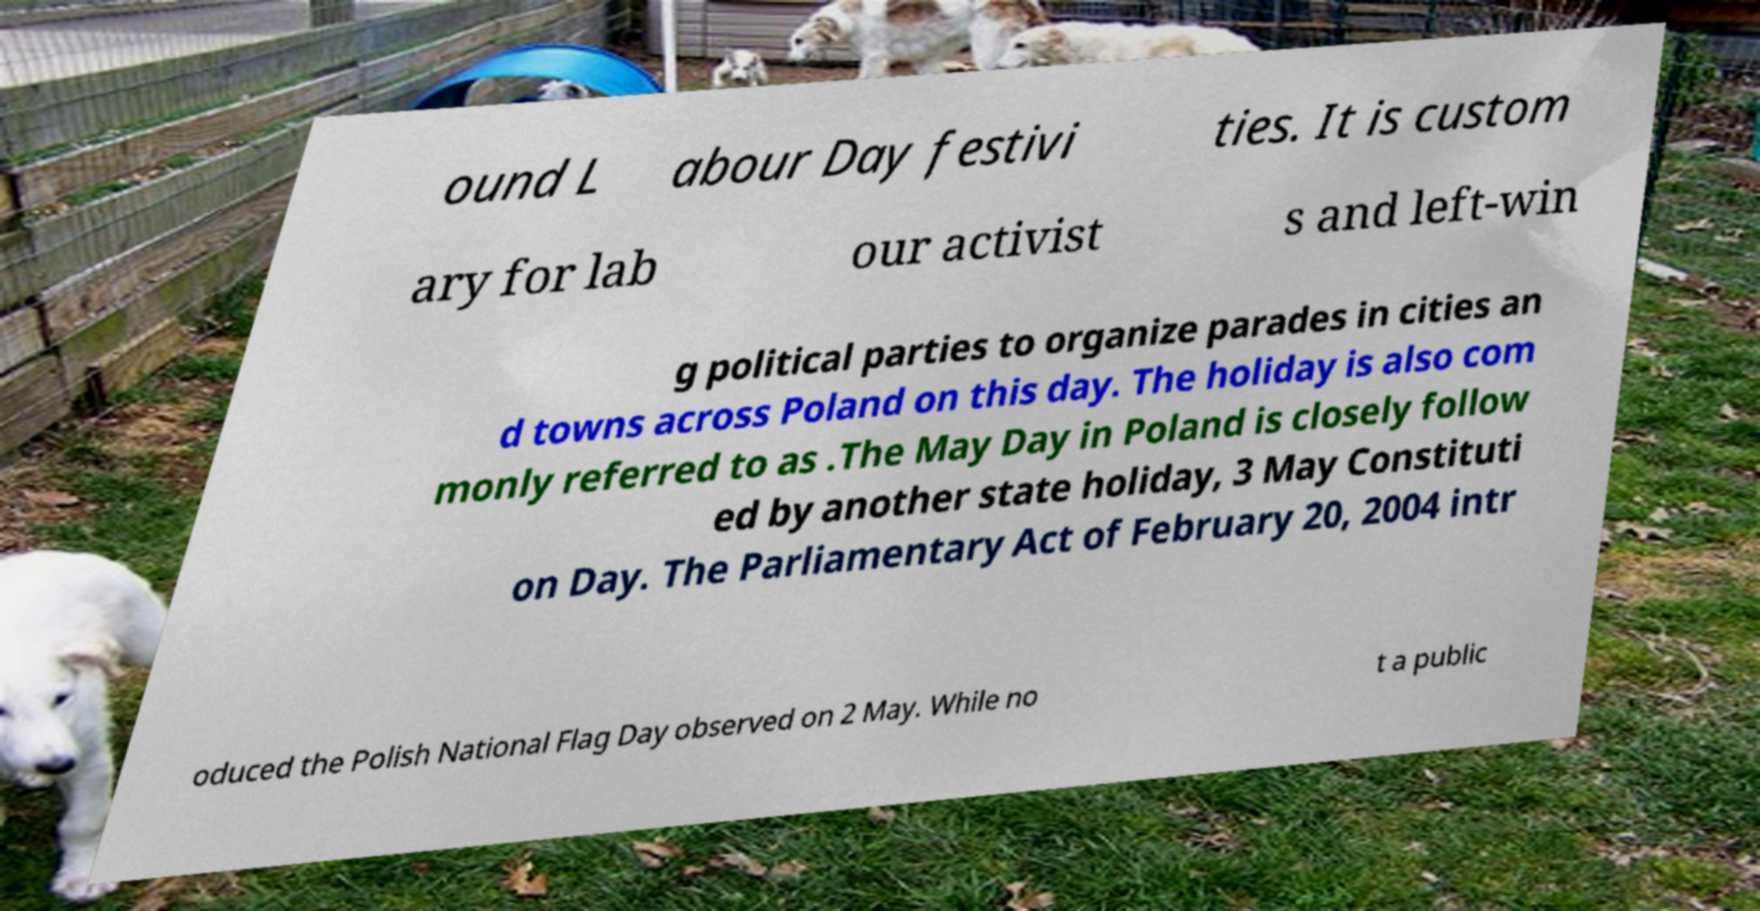There's text embedded in this image that I need extracted. Can you transcribe it verbatim? ound L abour Day festivi ties. It is custom ary for lab our activist s and left-win g political parties to organize parades in cities an d towns across Poland on this day. The holiday is also com monly referred to as .The May Day in Poland is closely follow ed by another state holiday, 3 May Constituti on Day. The Parliamentary Act of February 20, 2004 intr oduced the Polish National Flag Day observed on 2 May. While no t a public 